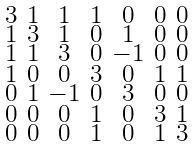Convert formula to latex. <formula><loc_0><loc_0><loc_500><loc_500>\begin{smallmatrix} 3 & 1 & 1 & 1 & 0 & 0 & 0 \\ 1 & 3 & 1 & 0 & 1 & 0 & 0 \\ 1 & 1 & 3 & 0 & - 1 & 0 & 0 \\ 1 & 0 & 0 & 3 & 0 & 1 & 1 \\ 0 & 1 & - 1 & 0 & 3 & 0 & 0 \\ 0 & 0 & 0 & 1 & 0 & 3 & 1 \\ 0 & 0 & 0 & 1 & 0 & 1 & 3 \end{smallmatrix}</formula> 